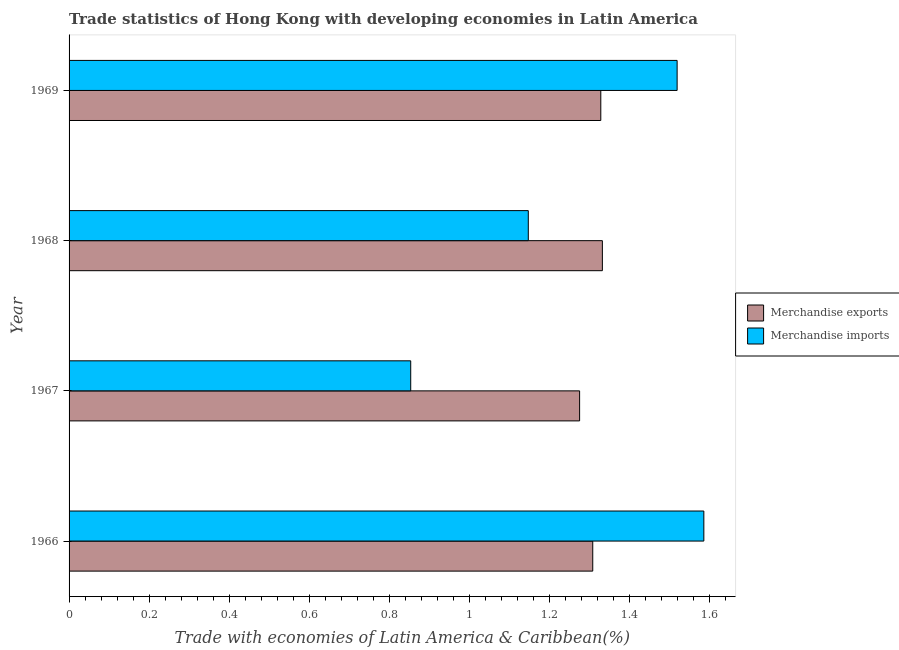How many different coloured bars are there?
Make the answer very short. 2. How many groups of bars are there?
Your answer should be compact. 4. Are the number of bars on each tick of the Y-axis equal?
Ensure brevity in your answer.  Yes. How many bars are there on the 3rd tick from the top?
Your answer should be compact. 2. What is the label of the 3rd group of bars from the top?
Provide a succinct answer. 1967. In how many cases, is the number of bars for a given year not equal to the number of legend labels?
Offer a terse response. 0. What is the merchandise imports in 1968?
Ensure brevity in your answer.  1.15. Across all years, what is the maximum merchandise exports?
Offer a very short reply. 1.33. Across all years, what is the minimum merchandise exports?
Offer a terse response. 1.28. In which year was the merchandise imports maximum?
Make the answer very short. 1966. In which year was the merchandise imports minimum?
Offer a terse response. 1967. What is the total merchandise imports in the graph?
Offer a very short reply. 5.11. What is the difference between the merchandise imports in 1967 and that in 1969?
Keep it short and to the point. -0.67. What is the difference between the merchandise exports in 1968 and the merchandise imports in 1969?
Provide a succinct answer. -0.19. What is the average merchandise exports per year?
Provide a short and direct response. 1.31. In the year 1969, what is the difference between the merchandise imports and merchandise exports?
Your answer should be very brief. 0.19. What is the ratio of the merchandise imports in 1967 to that in 1969?
Your answer should be compact. 0.56. Is the merchandise exports in 1967 less than that in 1969?
Offer a terse response. Yes. What is the difference between the highest and the second highest merchandise imports?
Provide a succinct answer. 0.07. What is the difference between the highest and the lowest merchandise exports?
Your response must be concise. 0.06. In how many years, is the merchandise exports greater than the average merchandise exports taken over all years?
Your answer should be compact. 2. What does the 2nd bar from the top in 1966 represents?
Your response must be concise. Merchandise exports. What does the 1st bar from the bottom in 1966 represents?
Offer a very short reply. Merchandise exports. Are all the bars in the graph horizontal?
Provide a short and direct response. Yes. Are the values on the major ticks of X-axis written in scientific E-notation?
Your response must be concise. No. Where does the legend appear in the graph?
Offer a terse response. Center right. How many legend labels are there?
Ensure brevity in your answer.  2. What is the title of the graph?
Your response must be concise. Trade statistics of Hong Kong with developing economies in Latin America. Does "Import" appear as one of the legend labels in the graph?
Give a very brief answer. No. What is the label or title of the X-axis?
Your answer should be compact. Trade with economies of Latin America & Caribbean(%). What is the Trade with economies of Latin America & Caribbean(%) of Merchandise exports in 1966?
Make the answer very short. 1.31. What is the Trade with economies of Latin America & Caribbean(%) in Merchandise imports in 1966?
Offer a very short reply. 1.59. What is the Trade with economies of Latin America & Caribbean(%) in Merchandise exports in 1967?
Offer a very short reply. 1.28. What is the Trade with economies of Latin America & Caribbean(%) in Merchandise imports in 1967?
Your answer should be compact. 0.85. What is the Trade with economies of Latin America & Caribbean(%) of Merchandise exports in 1968?
Offer a very short reply. 1.33. What is the Trade with economies of Latin America & Caribbean(%) in Merchandise imports in 1968?
Your response must be concise. 1.15. What is the Trade with economies of Latin America & Caribbean(%) of Merchandise exports in 1969?
Provide a short and direct response. 1.33. What is the Trade with economies of Latin America & Caribbean(%) in Merchandise imports in 1969?
Provide a succinct answer. 1.52. Across all years, what is the maximum Trade with economies of Latin America & Caribbean(%) in Merchandise exports?
Ensure brevity in your answer.  1.33. Across all years, what is the maximum Trade with economies of Latin America & Caribbean(%) in Merchandise imports?
Offer a very short reply. 1.59. Across all years, what is the minimum Trade with economies of Latin America & Caribbean(%) in Merchandise exports?
Your answer should be very brief. 1.28. Across all years, what is the minimum Trade with economies of Latin America & Caribbean(%) in Merchandise imports?
Offer a terse response. 0.85. What is the total Trade with economies of Latin America & Caribbean(%) of Merchandise exports in the graph?
Make the answer very short. 5.24. What is the total Trade with economies of Latin America & Caribbean(%) in Merchandise imports in the graph?
Your answer should be compact. 5.11. What is the difference between the Trade with economies of Latin America & Caribbean(%) in Merchandise exports in 1966 and that in 1967?
Make the answer very short. 0.03. What is the difference between the Trade with economies of Latin America & Caribbean(%) in Merchandise imports in 1966 and that in 1967?
Your answer should be compact. 0.73. What is the difference between the Trade with economies of Latin America & Caribbean(%) in Merchandise exports in 1966 and that in 1968?
Your response must be concise. -0.02. What is the difference between the Trade with economies of Latin America & Caribbean(%) in Merchandise imports in 1966 and that in 1968?
Make the answer very short. 0.44. What is the difference between the Trade with economies of Latin America & Caribbean(%) in Merchandise exports in 1966 and that in 1969?
Give a very brief answer. -0.02. What is the difference between the Trade with economies of Latin America & Caribbean(%) in Merchandise imports in 1966 and that in 1969?
Provide a short and direct response. 0.07. What is the difference between the Trade with economies of Latin America & Caribbean(%) in Merchandise exports in 1967 and that in 1968?
Your answer should be compact. -0.06. What is the difference between the Trade with economies of Latin America & Caribbean(%) of Merchandise imports in 1967 and that in 1968?
Make the answer very short. -0.29. What is the difference between the Trade with economies of Latin America & Caribbean(%) of Merchandise exports in 1967 and that in 1969?
Your answer should be very brief. -0.05. What is the difference between the Trade with economies of Latin America & Caribbean(%) in Merchandise imports in 1967 and that in 1969?
Give a very brief answer. -0.67. What is the difference between the Trade with economies of Latin America & Caribbean(%) of Merchandise exports in 1968 and that in 1969?
Provide a short and direct response. 0. What is the difference between the Trade with economies of Latin America & Caribbean(%) in Merchandise imports in 1968 and that in 1969?
Give a very brief answer. -0.37. What is the difference between the Trade with economies of Latin America & Caribbean(%) of Merchandise exports in 1966 and the Trade with economies of Latin America & Caribbean(%) of Merchandise imports in 1967?
Keep it short and to the point. 0.45. What is the difference between the Trade with economies of Latin America & Caribbean(%) of Merchandise exports in 1966 and the Trade with economies of Latin America & Caribbean(%) of Merchandise imports in 1968?
Ensure brevity in your answer.  0.16. What is the difference between the Trade with economies of Latin America & Caribbean(%) of Merchandise exports in 1966 and the Trade with economies of Latin America & Caribbean(%) of Merchandise imports in 1969?
Your answer should be very brief. -0.21. What is the difference between the Trade with economies of Latin America & Caribbean(%) in Merchandise exports in 1967 and the Trade with economies of Latin America & Caribbean(%) in Merchandise imports in 1968?
Ensure brevity in your answer.  0.13. What is the difference between the Trade with economies of Latin America & Caribbean(%) of Merchandise exports in 1967 and the Trade with economies of Latin America & Caribbean(%) of Merchandise imports in 1969?
Offer a terse response. -0.24. What is the difference between the Trade with economies of Latin America & Caribbean(%) of Merchandise exports in 1968 and the Trade with economies of Latin America & Caribbean(%) of Merchandise imports in 1969?
Offer a very short reply. -0.19. What is the average Trade with economies of Latin America & Caribbean(%) of Merchandise exports per year?
Your response must be concise. 1.31. What is the average Trade with economies of Latin America & Caribbean(%) of Merchandise imports per year?
Give a very brief answer. 1.28. In the year 1966, what is the difference between the Trade with economies of Latin America & Caribbean(%) in Merchandise exports and Trade with economies of Latin America & Caribbean(%) in Merchandise imports?
Keep it short and to the point. -0.28. In the year 1967, what is the difference between the Trade with economies of Latin America & Caribbean(%) in Merchandise exports and Trade with economies of Latin America & Caribbean(%) in Merchandise imports?
Give a very brief answer. 0.42. In the year 1968, what is the difference between the Trade with economies of Latin America & Caribbean(%) of Merchandise exports and Trade with economies of Latin America & Caribbean(%) of Merchandise imports?
Your answer should be compact. 0.19. In the year 1969, what is the difference between the Trade with economies of Latin America & Caribbean(%) of Merchandise exports and Trade with economies of Latin America & Caribbean(%) of Merchandise imports?
Provide a succinct answer. -0.19. What is the ratio of the Trade with economies of Latin America & Caribbean(%) of Merchandise exports in 1966 to that in 1967?
Your response must be concise. 1.03. What is the ratio of the Trade with economies of Latin America & Caribbean(%) in Merchandise imports in 1966 to that in 1967?
Offer a very short reply. 1.86. What is the ratio of the Trade with economies of Latin America & Caribbean(%) of Merchandise exports in 1966 to that in 1968?
Offer a very short reply. 0.98. What is the ratio of the Trade with economies of Latin America & Caribbean(%) in Merchandise imports in 1966 to that in 1968?
Provide a succinct answer. 1.38. What is the ratio of the Trade with economies of Latin America & Caribbean(%) of Merchandise exports in 1966 to that in 1969?
Provide a short and direct response. 0.98. What is the ratio of the Trade with economies of Latin America & Caribbean(%) in Merchandise imports in 1966 to that in 1969?
Offer a terse response. 1.04. What is the ratio of the Trade with economies of Latin America & Caribbean(%) in Merchandise exports in 1967 to that in 1968?
Ensure brevity in your answer.  0.96. What is the ratio of the Trade with economies of Latin America & Caribbean(%) of Merchandise imports in 1967 to that in 1968?
Provide a short and direct response. 0.74. What is the ratio of the Trade with economies of Latin America & Caribbean(%) in Merchandise exports in 1967 to that in 1969?
Ensure brevity in your answer.  0.96. What is the ratio of the Trade with economies of Latin America & Caribbean(%) of Merchandise imports in 1967 to that in 1969?
Offer a terse response. 0.56. What is the ratio of the Trade with economies of Latin America & Caribbean(%) in Merchandise exports in 1968 to that in 1969?
Keep it short and to the point. 1. What is the ratio of the Trade with economies of Latin America & Caribbean(%) in Merchandise imports in 1968 to that in 1969?
Make the answer very short. 0.76. What is the difference between the highest and the second highest Trade with economies of Latin America & Caribbean(%) of Merchandise exports?
Your answer should be compact. 0. What is the difference between the highest and the second highest Trade with economies of Latin America & Caribbean(%) of Merchandise imports?
Make the answer very short. 0.07. What is the difference between the highest and the lowest Trade with economies of Latin America & Caribbean(%) of Merchandise exports?
Ensure brevity in your answer.  0.06. What is the difference between the highest and the lowest Trade with economies of Latin America & Caribbean(%) in Merchandise imports?
Your answer should be compact. 0.73. 